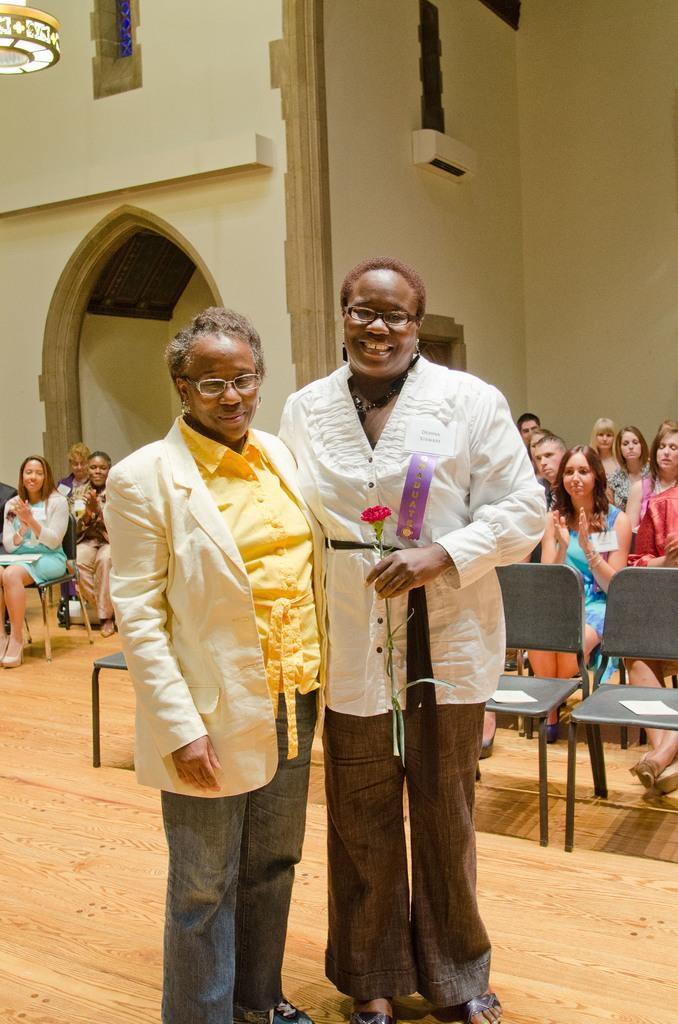How many people are present in the image? There are two people standing in the image. What is one of the people holding? One of the people is holding a rose. Can you describe the people in the background of the image? There is a group of people sitting in the background of the image. What type of bears can be seen participating in the discussion in the image? There are no bears present in the image, nor is there any discussion taking place. 